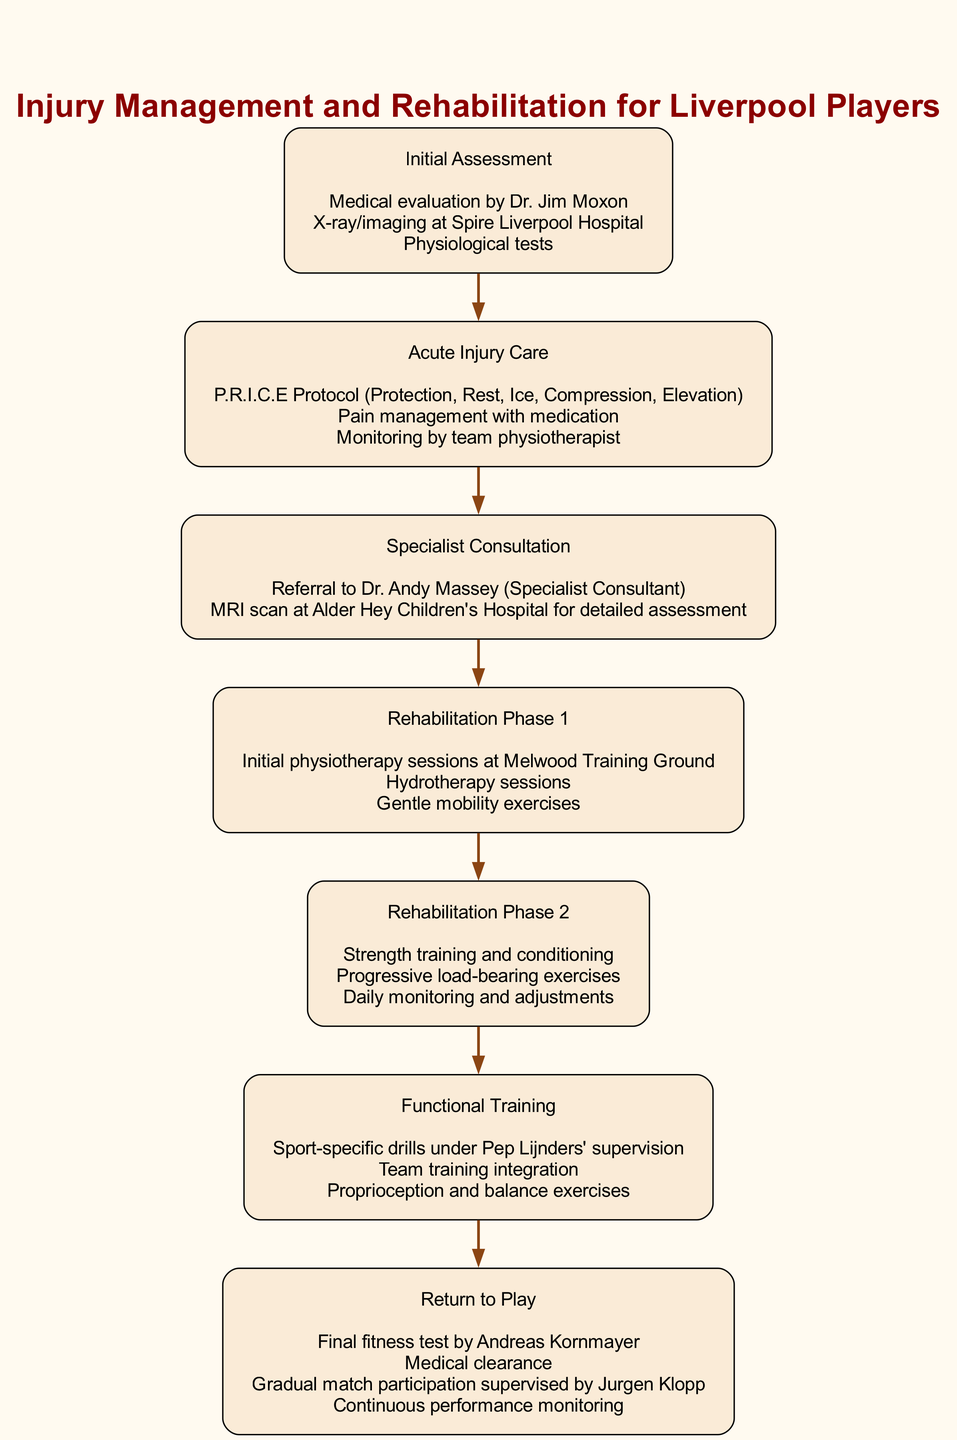What is the first step in the pathway? The first step listed in the diagram is "Initial Assessment." This is the topmost node and indicates the starting point of the clinical pathway for injury management.
Answer: Initial Assessment How many phases of rehabilitation are there? There are two distinct phases of rehabilitation in the pathway: "Rehabilitation Phase 1" and "Rehabilitation Phase 2." Counting them provides the number.
Answer: 2 Who supervises the functional training? "Functional Training" is supervised by Pep Lijnders, as indicated in the activities under that step. This connection can be traced directly in the diagram.
Answer: Pep Lijnders What is the last step before return to play? The last step before "Return to Play" is "Functional Training." By following the flow from the beginning, we see this as the penultimate step.
Answer: Functional Training What type of care is followed after initial assessment? The type of care following "Initial Assessment" is "Acute Injury Care," as shown by the direct progression from the first step to the second in the diagram's flow.
Answer: Acute Injury Care How many activities are listed under Rehabilitation Phase 2? There are three activities listed under "Rehabilitation Phase 2": "Strength training and conditioning," "Progressive load-bearing exercises," and "Daily monitoring and adjustments." Counting these activities gives the answer.
Answer: 3 What is the medical facility used for the MRI scan? The medical facility used for the MRI scan is "Alder Hey Children's Hospital," as specified under the "Specialist Consultation" step in the activities.
Answer: Alder Hey Children's Hospital Which step includes daily monitoring and adjustments? "Rehabilitation Phase 2" includes "Daily monitoring and adjustments" as part of its listed activities. This can be seen when looking at the activities of that specific step in the pathway.
Answer: Rehabilitation Phase 2 What protocol is followed during acute injury care? The protocol followed during "Acute Injury Care" is the "P.R.I.C.E Protocol (Protection, Rest, Ice, Compression, Elevation)," as described in the activities of that step.
Answer: P.R.I.C.E Protocol 